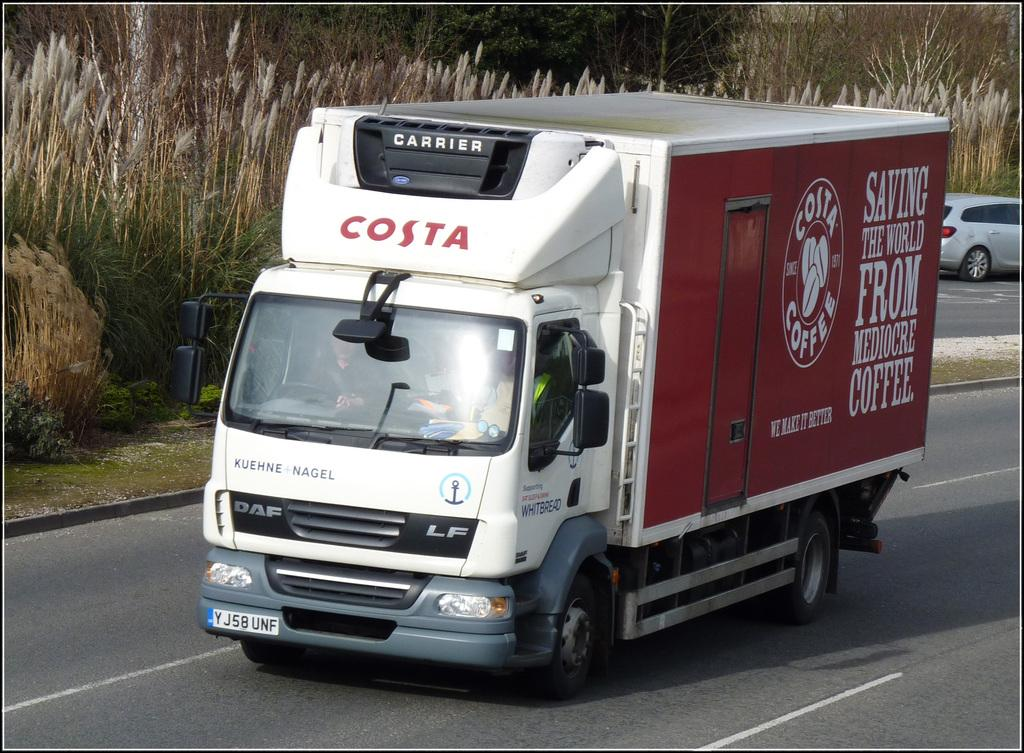What is happening on the road in the image? There are vehicles on the road in the image. What can be seen in the background of the image? There are plants visible in the background of the image. Can you describe any specific details about the truck in the image? Yes, there is a logo on a truck in the image, and there is something written on the truck. What type of plastic is used to create the country in the image? There is no country or plastic present in the image. 